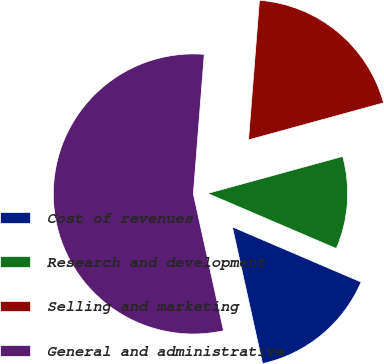Convert chart to OTSL. <chart><loc_0><loc_0><loc_500><loc_500><pie_chart><fcel>Cost of revenues<fcel>Research and development<fcel>Selling and marketing<fcel>General and administrative<nl><fcel>15.1%<fcel>10.7%<fcel>19.5%<fcel>54.7%<nl></chart> 